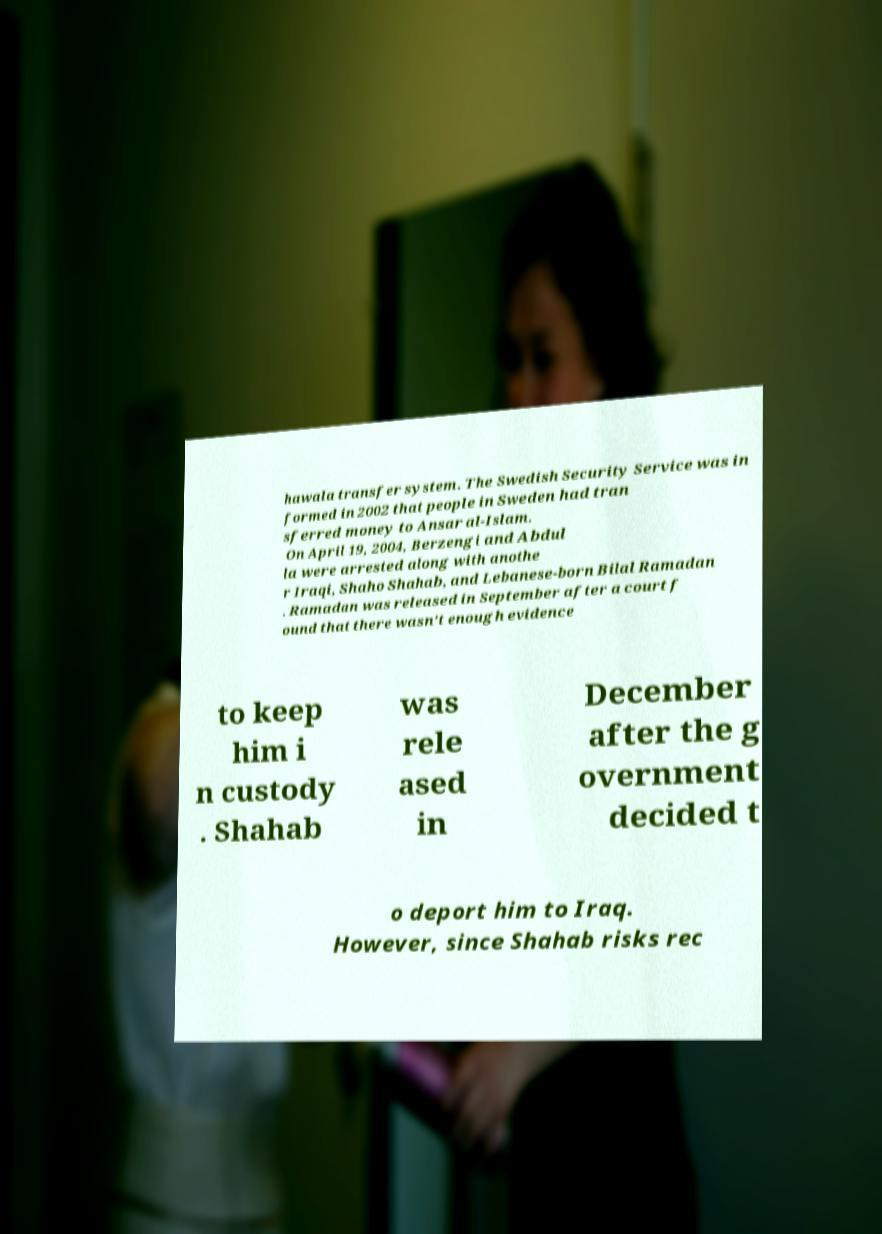Please read and relay the text visible in this image. What does it say? hawala transfer system. The Swedish Security Service was in formed in 2002 that people in Sweden had tran sferred money to Ansar al-Islam. On April 19, 2004, Berzengi and Abdul la were arrested along with anothe r Iraqi, Shaho Shahab, and Lebanese-born Bilal Ramadan . Ramadan was released in September after a court f ound that there wasn't enough evidence to keep him i n custody . Shahab was rele ased in December after the g overnment decided t o deport him to Iraq. However, since Shahab risks rec 